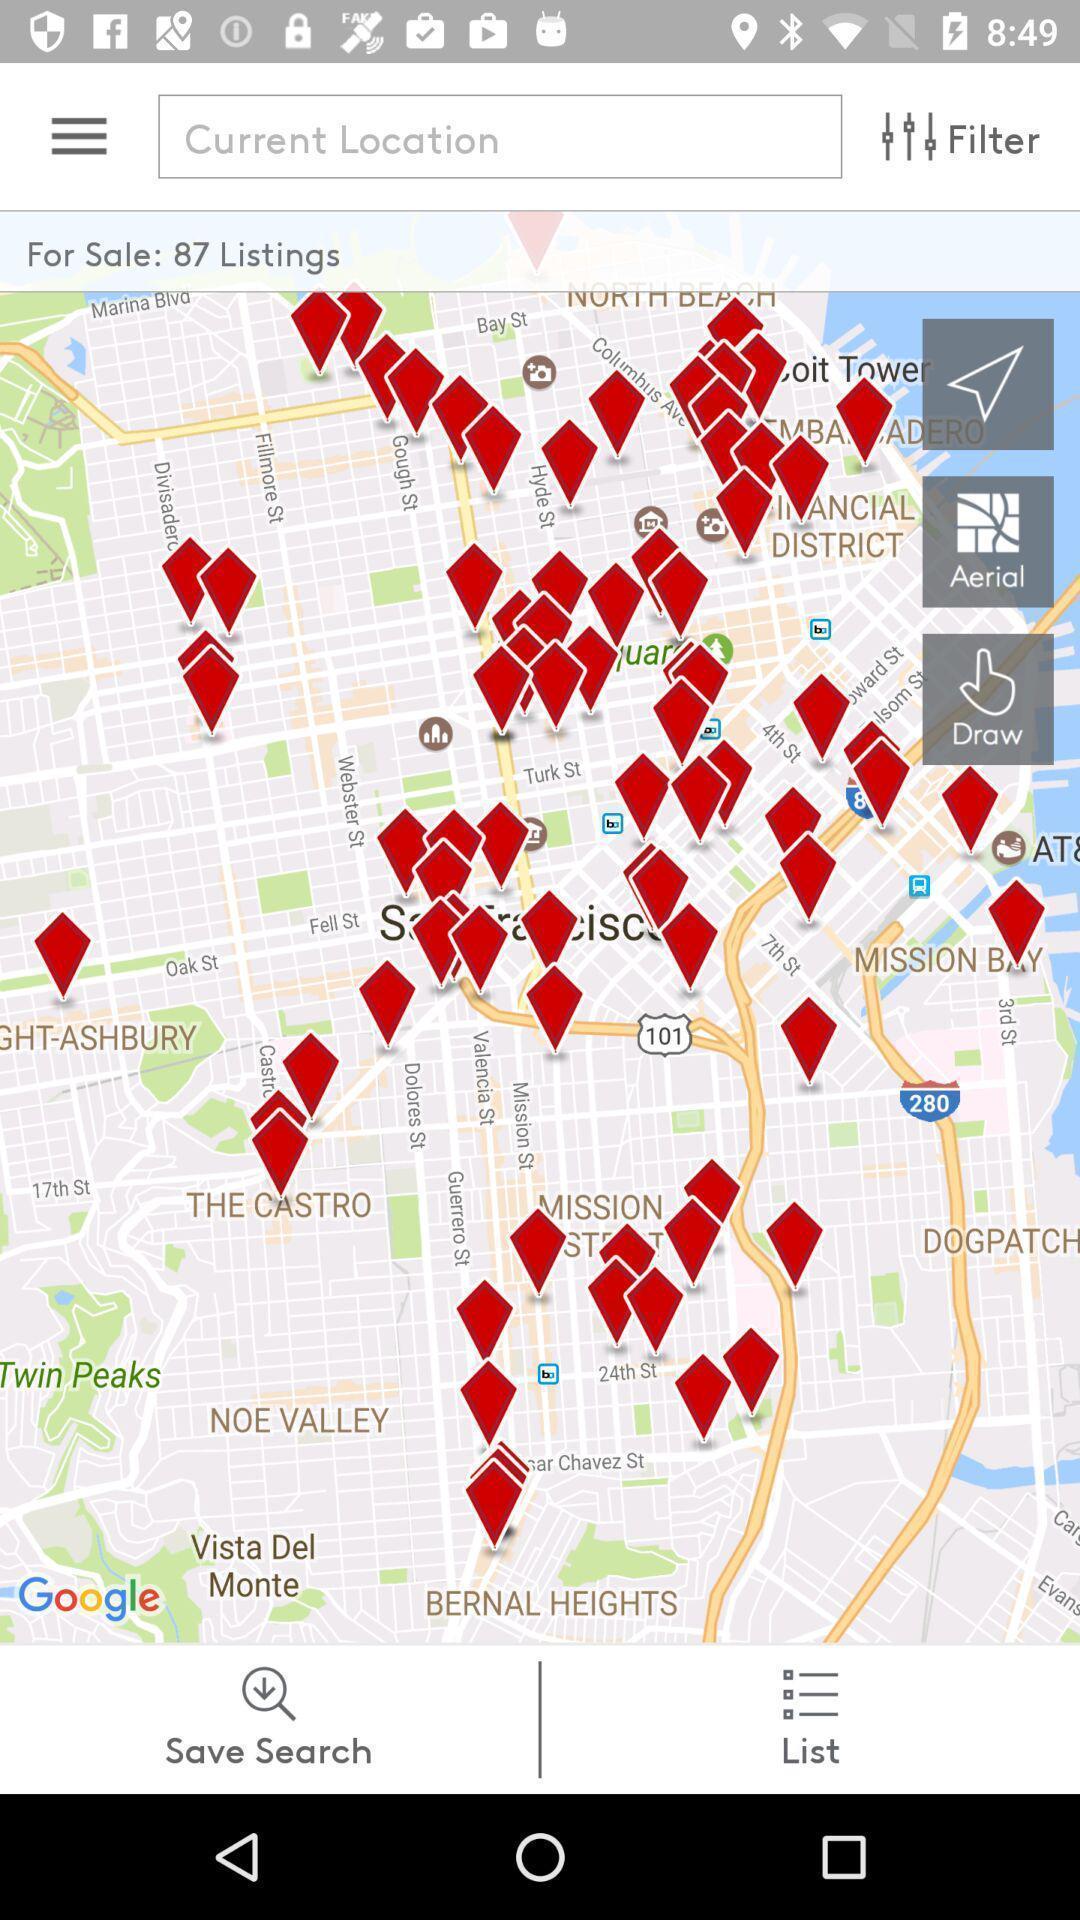Tell me about the visual elements in this screen capture. Screen shows search options. 